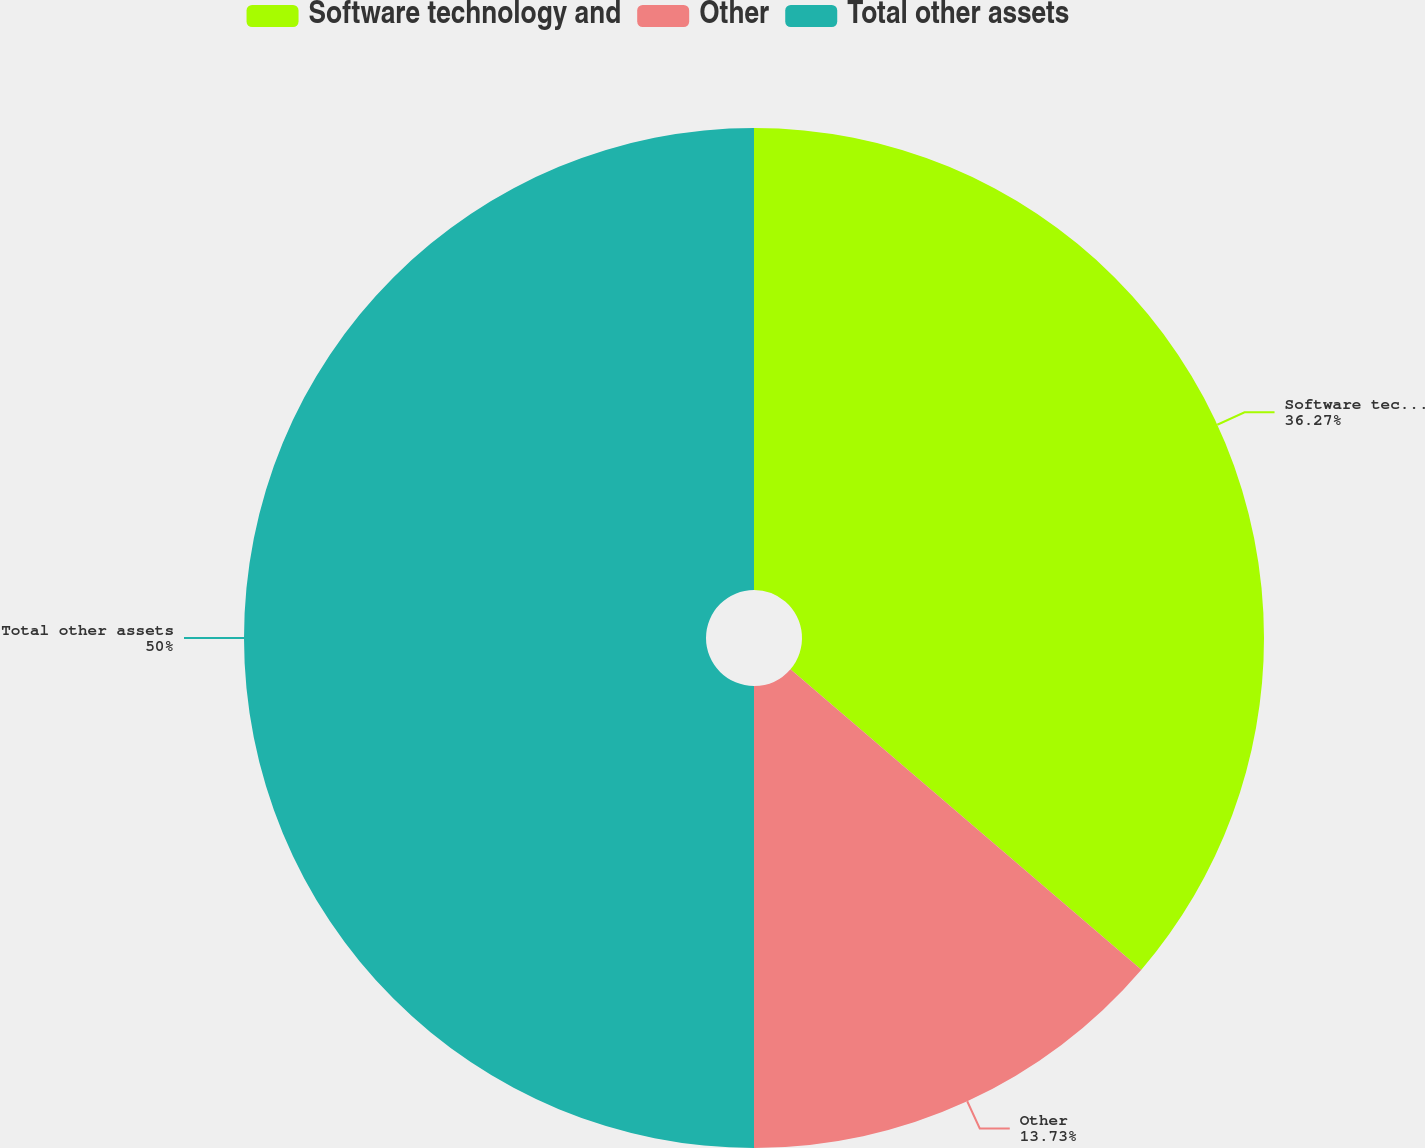Convert chart to OTSL. <chart><loc_0><loc_0><loc_500><loc_500><pie_chart><fcel>Software technology and<fcel>Other<fcel>Total other assets<nl><fcel>36.27%<fcel>13.73%<fcel>50.0%<nl></chart> 